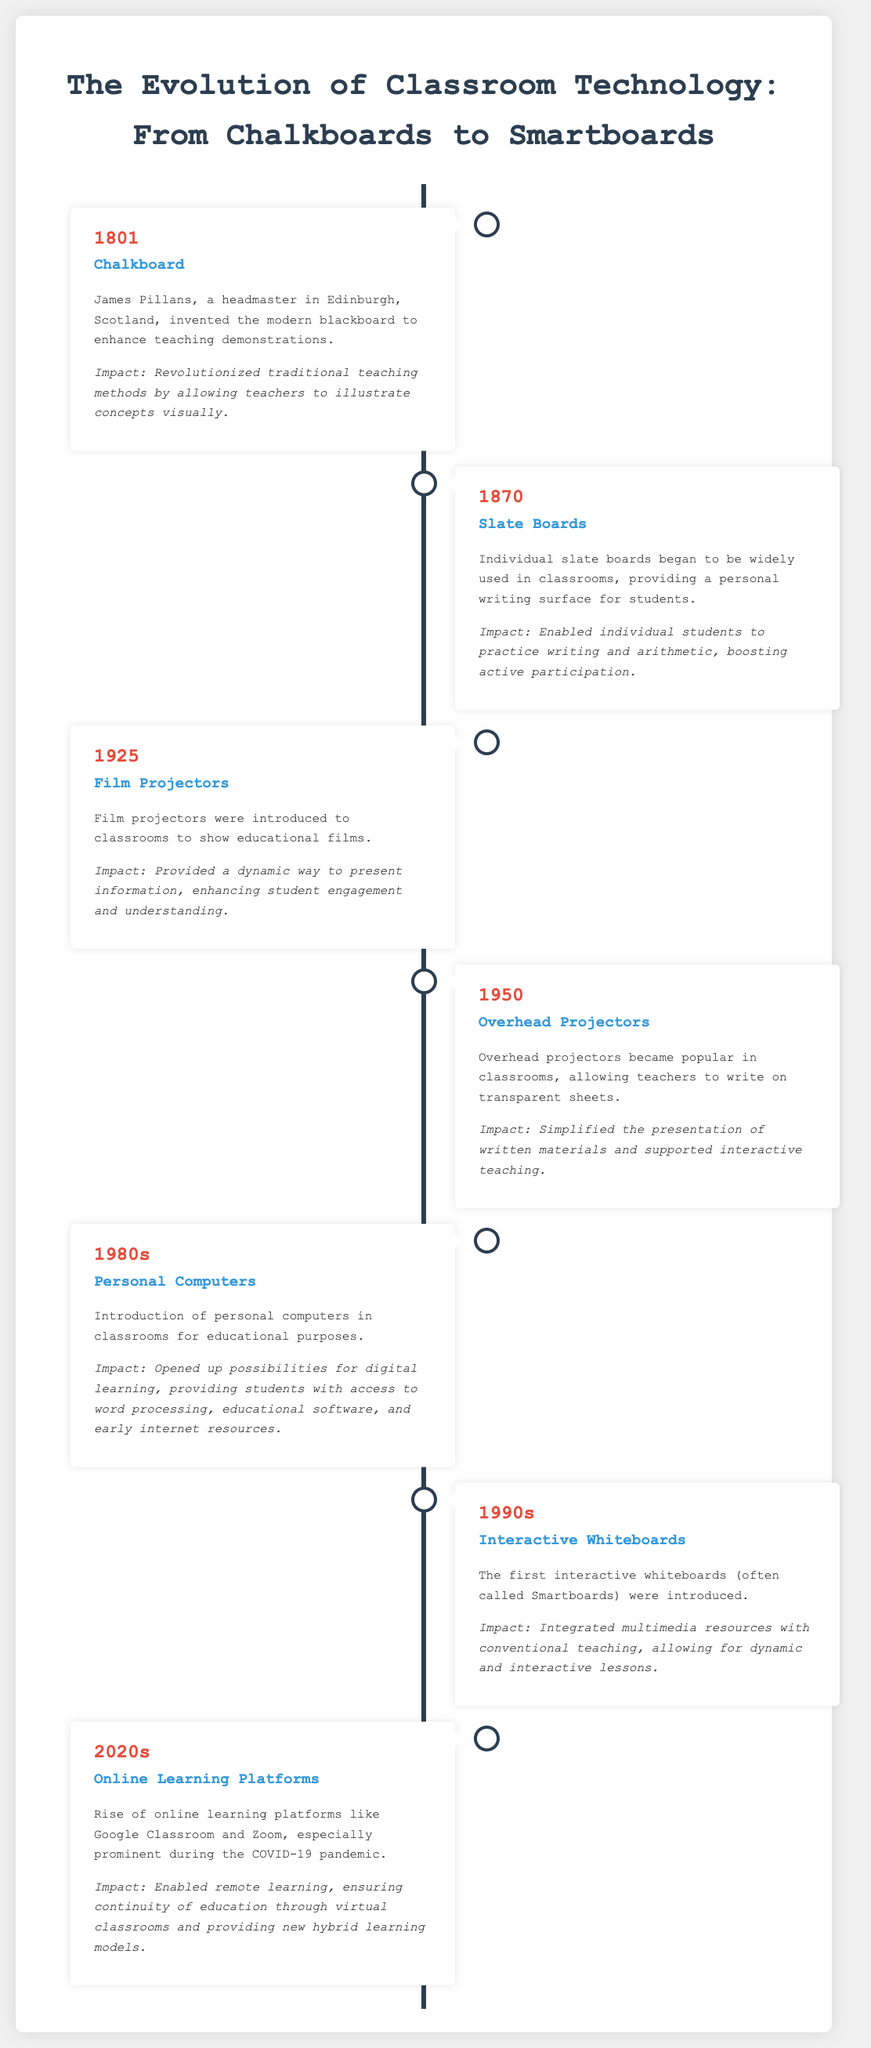What technology was invented in 1801? The technology mentioned for 1801 in the document is the Chalkboard, introduced by James Pillans.
Answer: Chalkboard What personal writing surface was introduced in the 1870s? The individual writing surface widely used in classrooms during the 1870s was the Slate Boards.
Answer: Slate Boards What year did film projectors become a classroom technology? The document states that film projectors were introduced in classrooms in the year 1925.
Answer: 1925 What technology simplified the presentation of materials in 1950? In 1950, Overhead Projectors simplified the presentation of written materials in classrooms.
Answer: Overhead Projectors What opened up digital learning opportunities in the 1980s? The introduction of Personal Computers in classrooms during the 1980s opened up opportunities for digital learning.
Answer: Personal Computers What classroom technology was prominent in the 1990s? The technology highlighted for the 1990s is Interactive Whiteboards.
Answer: Interactive Whiteboards Which decade saw the rise of online learning platforms? The document mentions that the rise of online learning platforms occurred in the 2020s.
Answer: 2020s What is the impact of online learning platforms according to the timeline? The impact mentioned is that they enabled remote learning and ensured continuity of education.
Answer: Enabled remote learning Which two classroom technologies were known for enhancing student engagement? The Film Projectors and Interactive Whiteboards were recognized in the document for enhancing student engagement.
Answer: Film Projectors and Interactive Whiteboards 